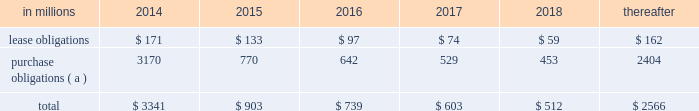At december 31 , 2013 , total future minimum commitments under existing non-cancelable operating leases and purchase obligations were as follows: .
( a ) includes $ 3.3 billion relating to fiber supply agreements entered into at the time of the company 2019s 2006 transformation plan forestland sales and in conjunction with the 2008 acquisition of weyerhaeuser company 2019s containerboard , packaging and recycling business .
Rent expense was $ 215 million , $ 231 million and $ 205 million for 2013 , 2012 and 2011 , respectively .
Guarantees in connection with sales of businesses , property , equipment , forestlands and other assets , international paper commonly makes representations and warranties relating to such businesses or assets , and may agree to indemnify buyers with respect to tax and environmental liabilities , breaches of representations and warranties , and other matters .
Where liabilities for such matters are determined to be probable and subject to reasonable estimation , accrued liabilities are recorded at the time of sale as a cost of the transaction .
Environmental proceedings international paper has been named as a potentially responsible party in environmental remediation actions under various federal and state laws , including the comprehensive environmental response , compensation and liability act ( cercla ) .
Many of these proceedings involve the cleanup of hazardous substances at large commercial landfills that received waste from many different sources .
While joint and several liability is authorized under cercla and equivalent state laws , as a practical matter , liability for cercla cleanups is typically allocated among the many potential responsible parties .
Remedial costs are recorded in the consolidated financial statements when they become probable and reasonably estimable .
International paper has estimated the probable liability associated with these matters to be approximately $ 94 million in the aggregate at december 31 , 2013 .
Cass lake : one of the matters referenced above is a closed wood treating facility located in cass lake , minnesota .
During 2009 , in connection with an environmental site remediation action under cercla , international paper submitted to the epa a site remediation feasibility study .
In june 2011 , the epa selected and published a proposed soil remedy at the site with an estimated cost of $ 46 million .
The overall remediation reserve for the site is currently $ 51 million to address this selection of an alternative for the soil remediation component of the overall site remedy .
In october 2011 , the epa released a public statement indicating that the final soil remedy decision would be delayed .
In the unlikely event that the epa changes its proposed soil remedy and approves instead a more expensive clean-up alternative , the remediation costs could be material , and significantly higher than amounts currently recorded .
In october 2012 , the natural resource trustees for this site provided notice to international paper and other potentially responsible parties of their intent to perform a natural resource damage assessment .
It is premature to predict the outcome of the assessment or to estimate a loss or range of loss , if any , which may be incurred .
Other : in addition to the above matters , other remediation costs typically associated with the cleanup of hazardous substances at the company 2019s current , closed or formerly-owned facilities , and recorded as liabilities in the balance sheet , totaled approximately $ 42 million at december 31 , 2013 .
Other than as described above , completion of required remedial actions is not expected to have a material effect on our consolidated financial statements .
Kalamazoo river : the company is a potentially responsible party with respect to the allied paper , inc./ portage creek/kalamazoo river superfund site ( kalamazoo river superfund site ) in michigan .
The epa asserts that the site is contaminated primarily by pcbs as a result of discharges from various paper mills located along the kalamazoo river , including a paper mill formerly owned by st .
Regis paper company ( st .
Regis ) .
The company is a successor in interest to st .
Regis .
The company has not received any orders from the epa with respect to the site and continues to collect information from the epa and other parties relative to the site to evaluate the extent of its liability , if any , with respect to the site .
Accordingly , it is premature to estimate a loss or range of loss with respect to this site .
Also in connection with the kalamazoo river superfund site , the company was named as a defendant by georgia-pacific consumer products lp , fort james corporation and georgia pacific llc in a contribution and cost recovery action for alleged pollution at the site .
The suit seeks contribution under cercla for $ 79 million in costs purportedly expended by plaintiffs as of the filing of the complaint and for future remediation costs .
The suit alleges that a mill , during the time it was allegedly owned and operated by st .
Regis , discharged pcb contaminated solids and paper residuals resulting from paper de-inking and recycling .
Also named as defendants in the suit are ncr corporation and weyerhaeuser company .
In mid-2011 , the suit was transferred from the district court for the eastern district of wisconsin to the district court for the western .
What was the cumulative rent expense from 2011 to 2013? 
Computations: (205 + (215 + 231))
Answer: 651.0. 